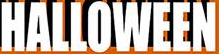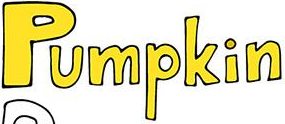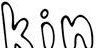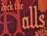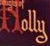Read the text content from these images in order, separated by a semicolon. HALLOWEEN; Pumpkin; kin; Halls; Holly 